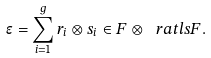<formula> <loc_0><loc_0><loc_500><loc_500>\epsilon = \sum _ { i = 1 } ^ { g } r _ { i } \otimes s _ { i } \in F \otimes _ { \ } r a t l s F .</formula> 